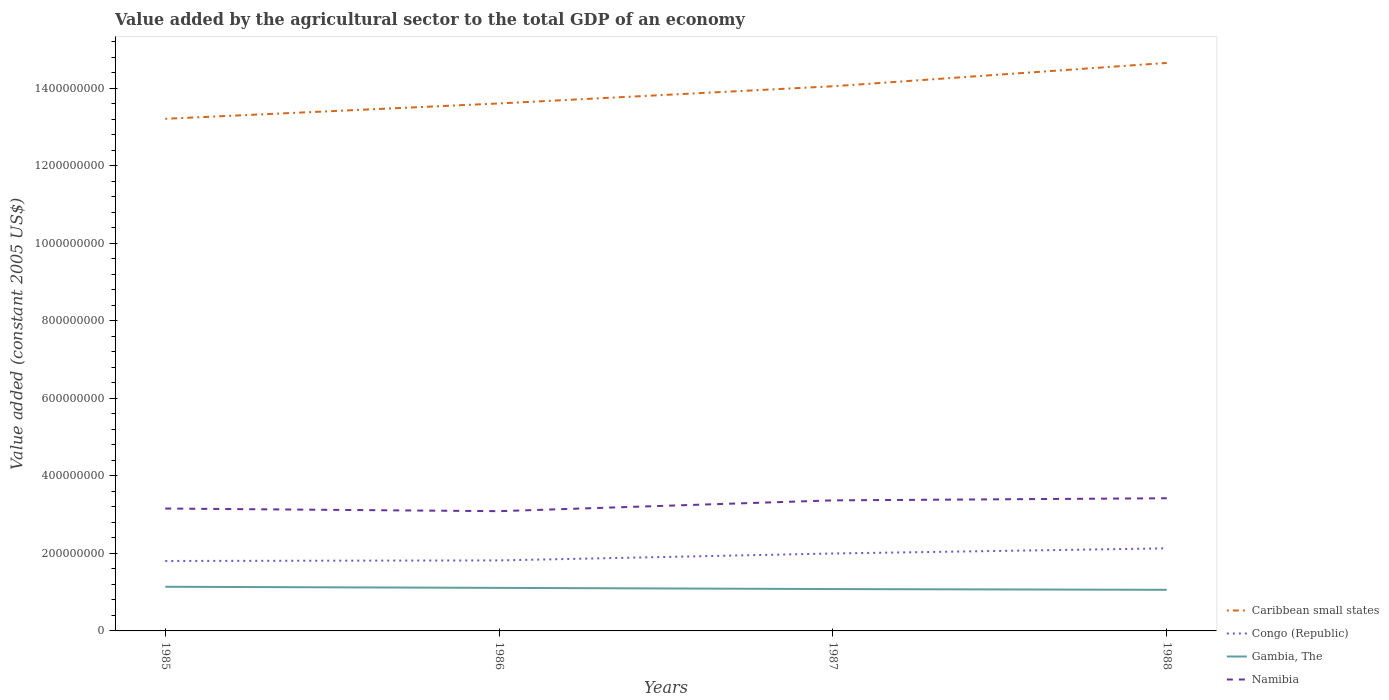How many different coloured lines are there?
Make the answer very short. 4. Does the line corresponding to Gambia, The intersect with the line corresponding to Namibia?
Keep it short and to the point. No. Across all years, what is the maximum value added by the agricultural sector in Congo (Republic)?
Offer a terse response. 1.80e+08. In which year was the value added by the agricultural sector in Caribbean small states maximum?
Your answer should be very brief. 1985. What is the total value added by the agricultural sector in Caribbean small states in the graph?
Keep it short and to the point. -6.02e+07. What is the difference between the highest and the second highest value added by the agricultural sector in Congo (Republic)?
Make the answer very short. 3.26e+07. What is the difference between the highest and the lowest value added by the agricultural sector in Namibia?
Offer a very short reply. 2. Is the value added by the agricultural sector in Namibia strictly greater than the value added by the agricultural sector in Gambia, The over the years?
Provide a succinct answer. No. What is the difference between two consecutive major ticks on the Y-axis?
Ensure brevity in your answer.  2.00e+08. Does the graph contain grids?
Ensure brevity in your answer.  No. How many legend labels are there?
Offer a terse response. 4. What is the title of the graph?
Provide a short and direct response. Value added by the agricultural sector to the total GDP of an economy. What is the label or title of the X-axis?
Make the answer very short. Years. What is the label or title of the Y-axis?
Offer a very short reply. Value added (constant 2005 US$). What is the Value added (constant 2005 US$) in Caribbean small states in 1985?
Provide a short and direct response. 1.32e+09. What is the Value added (constant 2005 US$) of Congo (Republic) in 1985?
Make the answer very short. 1.80e+08. What is the Value added (constant 2005 US$) of Gambia, The in 1985?
Make the answer very short. 1.14e+08. What is the Value added (constant 2005 US$) in Namibia in 1985?
Offer a terse response. 3.16e+08. What is the Value added (constant 2005 US$) of Caribbean small states in 1986?
Give a very brief answer. 1.36e+09. What is the Value added (constant 2005 US$) of Congo (Republic) in 1986?
Give a very brief answer. 1.82e+08. What is the Value added (constant 2005 US$) in Gambia, The in 1986?
Provide a short and direct response. 1.11e+08. What is the Value added (constant 2005 US$) in Namibia in 1986?
Ensure brevity in your answer.  3.09e+08. What is the Value added (constant 2005 US$) of Caribbean small states in 1987?
Your answer should be very brief. 1.41e+09. What is the Value added (constant 2005 US$) in Congo (Republic) in 1987?
Keep it short and to the point. 2.00e+08. What is the Value added (constant 2005 US$) of Gambia, The in 1987?
Your response must be concise. 1.08e+08. What is the Value added (constant 2005 US$) of Namibia in 1987?
Make the answer very short. 3.37e+08. What is the Value added (constant 2005 US$) in Caribbean small states in 1988?
Your answer should be very brief. 1.47e+09. What is the Value added (constant 2005 US$) in Congo (Republic) in 1988?
Your answer should be compact. 2.13e+08. What is the Value added (constant 2005 US$) in Gambia, The in 1988?
Your answer should be compact. 1.06e+08. What is the Value added (constant 2005 US$) in Namibia in 1988?
Your response must be concise. 3.42e+08. Across all years, what is the maximum Value added (constant 2005 US$) in Caribbean small states?
Make the answer very short. 1.47e+09. Across all years, what is the maximum Value added (constant 2005 US$) in Congo (Republic)?
Provide a short and direct response. 2.13e+08. Across all years, what is the maximum Value added (constant 2005 US$) of Gambia, The?
Your response must be concise. 1.14e+08. Across all years, what is the maximum Value added (constant 2005 US$) in Namibia?
Your answer should be compact. 3.42e+08. Across all years, what is the minimum Value added (constant 2005 US$) of Caribbean small states?
Make the answer very short. 1.32e+09. Across all years, what is the minimum Value added (constant 2005 US$) in Congo (Republic)?
Offer a very short reply. 1.80e+08. Across all years, what is the minimum Value added (constant 2005 US$) of Gambia, The?
Provide a succinct answer. 1.06e+08. Across all years, what is the minimum Value added (constant 2005 US$) of Namibia?
Provide a short and direct response. 3.09e+08. What is the total Value added (constant 2005 US$) in Caribbean small states in the graph?
Give a very brief answer. 5.55e+09. What is the total Value added (constant 2005 US$) of Congo (Republic) in the graph?
Provide a short and direct response. 7.75e+08. What is the total Value added (constant 2005 US$) in Gambia, The in the graph?
Make the answer very short. 4.39e+08. What is the total Value added (constant 2005 US$) in Namibia in the graph?
Give a very brief answer. 1.30e+09. What is the difference between the Value added (constant 2005 US$) of Caribbean small states in 1985 and that in 1986?
Your answer should be very brief. -3.96e+07. What is the difference between the Value added (constant 2005 US$) of Congo (Republic) in 1985 and that in 1986?
Give a very brief answer. -1.46e+06. What is the difference between the Value added (constant 2005 US$) in Gambia, The in 1985 and that in 1986?
Your answer should be very brief. 2.87e+06. What is the difference between the Value added (constant 2005 US$) in Namibia in 1985 and that in 1986?
Your answer should be very brief. 6.80e+06. What is the difference between the Value added (constant 2005 US$) in Caribbean small states in 1985 and that in 1987?
Give a very brief answer. -8.39e+07. What is the difference between the Value added (constant 2005 US$) of Congo (Republic) in 1985 and that in 1987?
Provide a short and direct response. -1.93e+07. What is the difference between the Value added (constant 2005 US$) in Gambia, The in 1985 and that in 1987?
Your answer should be very brief. 5.93e+06. What is the difference between the Value added (constant 2005 US$) of Namibia in 1985 and that in 1987?
Ensure brevity in your answer.  -2.11e+07. What is the difference between the Value added (constant 2005 US$) in Caribbean small states in 1985 and that in 1988?
Your response must be concise. -1.44e+08. What is the difference between the Value added (constant 2005 US$) in Congo (Republic) in 1985 and that in 1988?
Offer a terse response. -3.26e+07. What is the difference between the Value added (constant 2005 US$) of Gambia, The in 1985 and that in 1988?
Provide a succinct answer. 7.88e+06. What is the difference between the Value added (constant 2005 US$) in Namibia in 1985 and that in 1988?
Your answer should be very brief. -2.65e+07. What is the difference between the Value added (constant 2005 US$) of Caribbean small states in 1986 and that in 1987?
Make the answer very short. -4.43e+07. What is the difference between the Value added (constant 2005 US$) of Congo (Republic) in 1986 and that in 1987?
Offer a terse response. -1.79e+07. What is the difference between the Value added (constant 2005 US$) in Gambia, The in 1986 and that in 1987?
Give a very brief answer. 3.06e+06. What is the difference between the Value added (constant 2005 US$) of Namibia in 1986 and that in 1987?
Offer a very short reply. -2.79e+07. What is the difference between the Value added (constant 2005 US$) in Caribbean small states in 1986 and that in 1988?
Offer a terse response. -1.05e+08. What is the difference between the Value added (constant 2005 US$) of Congo (Republic) in 1986 and that in 1988?
Your answer should be compact. -3.11e+07. What is the difference between the Value added (constant 2005 US$) of Gambia, The in 1986 and that in 1988?
Your answer should be very brief. 5.01e+06. What is the difference between the Value added (constant 2005 US$) of Namibia in 1986 and that in 1988?
Your response must be concise. -3.34e+07. What is the difference between the Value added (constant 2005 US$) in Caribbean small states in 1987 and that in 1988?
Ensure brevity in your answer.  -6.02e+07. What is the difference between the Value added (constant 2005 US$) in Congo (Republic) in 1987 and that in 1988?
Offer a terse response. -1.33e+07. What is the difference between the Value added (constant 2005 US$) in Gambia, The in 1987 and that in 1988?
Offer a terse response. 1.94e+06. What is the difference between the Value added (constant 2005 US$) of Namibia in 1987 and that in 1988?
Provide a succinct answer. -5.46e+06. What is the difference between the Value added (constant 2005 US$) in Caribbean small states in 1985 and the Value added (constant 2005 US$) in Congo (Republic) in 1986?
Your answer should be compact. 1.14e+09. What is the difference between the Value added (constant 2005 US$) in Caribbean small states in 1985 and the Value added (constant 2005 US$) in Gambia, The in 1986?
Offer a terse response. 1.21e+09. What is the difference between the Value added (constant 2005 US$) of Caribbean small states in 1985 and the Value added (constant 2005 US$) of Namibia in 1986?
Your response must be concise. 1.01e+09. What is the difference between the Value added (constant 2005 US$) of Congo (Republic) in 1985 and the Value added (constant 2005 US$) of Gambia, The in 1986?
Keep it short and to the point. 6.94e+07. What is the difference between the Value added (constant 2005 US$) of Congo (Republic) in 1985 and the Value added (constant 2005 US$) of Namibia in 1986?
Offer a very short reply. -1.28e+08. What is the difference between the Value added (constant 2005 US$) in Gambia, The in 1985 and the Value added (constant 2005 US$) in Namibia in 1986?
Provide a short and direct response. -1.95e+08. What is the difference between the Value added (constant 2005 US$) in Caribbean small states in 1985 and the Value added (constant 2005 US$) in Congo (Republic) in 1987?
Offer a terse response. 1.12e+09. What is the difference between the Value added (constant 2005 US$) of Caribbean small states in 1985 and the Value added (constant 2005 US$) of Gambia, The in 1987?
Make the answer very short. 1.21e+09. What is the difference between the Value added (constant 2005 US$) of Caribbean small states in 1985 and the Value added (constant 2005 US$) of Namibia in 1987?
Provide a succinct answer. 9.84e+08. What is the difference between the Value added (constant 2005 US$) in Congo (Republic) in 1985 and the Value added (constant 2005 US$) in Gambia, The in 1987?
Your answer should be very brief. 7.25e+07. What is the difference between the Value added (constant 2005 US$) of Congo (Republic) in 1985 and the Value added (constant 2005 US$) of Namibia in 1987?
Your answer should be compact. -1.56e+08. What is the difference between the Value added (constant 2005 US$) in Gambia, The in 1985 and the Value added (constant 2005 US$) in Namibia in 1987?
Make the answer very short. -2.23e+08. What is the difference between the Value added (constant 2005 US$) of Caribbean small states in 1985 and the Value added (constant 2005 US$) of Congo (Republic) in 1988?
Provide a short and direct response. 1.11e+09. What is the difference between the Value added (constant 2005 US$) in Caribbean small states in 1985 and the Value added (constant 2005 US$) in Gambia, The in 1988?
Offer a very short reply. 1.22e+09. What is the difference between the Value added (constant 2005 US$) of Caribbean small states in 1985 and the Value added (constant 2005 US$) of Namibia in 1988?
Keep it short and to the point. 9.79e+08. What is the difference between the Value added (constant 2005 US$) of Congo (Republic) in 1985 and the Value added (constant 2005 US$) of Gambia, The in 1988?
Your response must be concise. 7.44e+07. What is the difference between the Value added (constant 2005 US$) in Congo (Republic) in 1985 and the Value added (constant 2005 US$) in Namibia in 1988?
Your answer should be very brief. -1.62e+08. What is the difference between the Value added (constant 2005 US$) of Gambia, The in 1985 and the Value added (constant 2005 US$) of Namibia in 1988?
Offer a terse response. -2.28e+08. What is the difference between the Value added (constant 2005 US$) in Caribbean small states in 1986 and the Value added (constant 2005 US$) in Congo (Republic) in 1987?
Your answer should be very brief. 1.16e+09. What is the difference between the Value added (constant 2005 US$) in Caribbean small states in 1986 and the Value added (constant 2005 US$) in Gambia, The in 1987?
Ensure brevity in your answer.  1.25e+09. What is the difference between the Value added (constant 2005 US$) in Caribbean small states in 1986 and the Value added (constant 2005 US$) in Namibia in 1987?
Provide a short and direct response. 1.02e+09. What is the difference between the Value added (constant 2005 US$) of Congo (Republic) in 1986 and the Value added (constant 2005 US$) of Gambia, The in 1987?
Your answer should be compact. 7.39e+07. What is the difference between the Value added (constant 2005 US$) in Congo (Republic) in 1986 and the Value added (constant 2005 US$) in Namibia in 1987?
Your response must be concise. -1.55e+08. What is the difference between the Value added (constant 2005 US$) of Gambia, The in 1986 and the Value added (constant 2005 US$) of Namibia in 1987?
Keep it short and to the point. -2.26e+08. What is the difference between the Value added (constant 2005 US$) in Caribbean small states in 1986 and the Value added (constant 2005 US$) in Congo (Republic) in 1988?
Provide a short and direct response. 1.15e+09. What is the difference between the Value added (constant 2005 US$) in Caribbean small states in 1986 and the Value added (constant 2005 US$) in Gambia, The in 1988?
Ensure brevity in your answer.  1.25e+09. What is the difference between the Value added (constant 2005 US$) in Caribbean small states in 1986 and the Value added (constant 2005 US$) in Namibia in 1988?
Keep it short and to the point. 1.02e+09. What is the difference between the Value added (constant 2005 US$) of Congo (Republic) in 1986 and the Value added (constant 2005 US$) of Gambia, The in 1988?
Provide a succinct answer. 7.59e+07. What is the difference between the Value added (constant 2005 US$) in Congo (Republic) in 1986 and the Value added (constant 2005 US$) in Namibia in 1988?
Your answer should be very brief. -1.60e+08. What is the difference between the Value added (constant 2005 US$) of Gambia, The in 1986 and the Value added (constant 2005 US$) of Namibia in 1988?
Provide a short and direct response. -2.31e+08. What is the difference between the Value added (constant 2005 US$) in Caribbean small states in 1987 and the Value added (constant 2005 US$) in Congo (Republic) in 1988?
Give a very brief answer. 1.19e+09. What is the difference between the Value added (constant 2005 US$) in Caribbean small states in 1987 and the Value added (constant 2005 US$) in Gambia, The in 1988?
Your answer should be very brief. 1.30e+09. What is the difference between the Value added (constant 2005 US$) of Caribbean small states in 1987 and the Value added (constant 2005 US$) of Namibia in 1988?
Provide a succinct answer. 1.06e+09. What is the difference between the Value added (constant 2005 US$) of Congo (Republic) in 1987 and the Value added (constant 2005 US$) of Gambia, The in 1988?
Give a very brief answer. 9.37e+07. What is the difference between the Value added (constant 2005 US$) in Congo (Republic) in 1987 and the Value added (constant 2005 US$) in Namibia in 1988?
Your response must be concise. -1.43e+08. What is the difference between the Value added (constant 2005 US$) in Gambia, The in 1987 and the Value added (constant 2005 US$) in Namibia in 1988?
Offer a very short reply. -2.34e+08. What is the average Value added (constant 2005 US$) in Caribbean small states per year?
Your answer should be very brief. 1.39e+09. What is the average Value added (constant 2005 US$) of Congo (Republic) per year?
Provide a short and direct response. 1.94e+08. What is the average Value added (constant 2005 US$) of Gambia, The per year?
Ensure brevity in your answer.  1.10e+08. What is the average Value added (constant 2005 US$) in Namibia per year?
Your response must be concise. 3.26e+08. In the year 1985, what is the difference between the Value added (constant 2005 US$) in Caribbean small states and Value added (constant 2005 US$) in Congo (Republic)?
Your answer should be very brief. 1.14e+09. In the year 1985, what is the difference between the Value added (constant 2005 US$) in Caribbean small states and Value added (constant 2005 US$) in Gambia, The?
Give a very brief answer. 1.21e+09. In the year 1985, what is the difference between the Value added (constant 2005 US$) of Caribbean small states and Value added (constant 2005 US$) of Namibia?
Provide a succinct answer. 1.01e+09. In the year 1985, what is the difference between the Value added (constant 2005 US$) of Congo (Republic) and Value added (constant 2005 US$) of Gambia, The?
Provide a succinct answer. 6.65e+07. In the year 1985, what is the difference between the Value added (constant 2005 US$) of Congo (Republic) and Value added (constant 2005 US$) of Namibia?
Offer a very short reply. -1.35e+08. In the year 1985, what is the difference between the Value added (constant 2005 US$) in Gambia, The and Value added (constant 2005 US$) in Namibia?
Provide a succinct answer. -2.02e+08. In the year 1986, what is the difference between the Value added (constant 2005 US$) of Caribbean small states and Value added (constant 2005 US$) of Congo (Republic)?
Keep it short and to the point. 1.18e+09. In the year 1986, what is the difference between the Value added (constant 2005 US$) in Caribbean small states and Value added (constant 2005 US$) in Gambia, The?
Ensure brevity in your answer.  1.25e+09. In the year 1986, what is the difference between the Value added (constant 2005 US$) of Caribbean small states and Value added (constant 2005 US$) of Namibia?
Your answer should be compact. 1.05e+09. In the year 1986, what is the difference between the Value added (constant 2005 US$) of Congo (Republic) and Value added (constant 2005 US$) of Gambia, The?
Your answer should be very brief. 7.09e+07. In the year 1986, what is the difference between the Value added (constant 2005 US$) of Congo (Republic) and Value added (constant 2005 US$) of Namibia?
Keep it short and to the point. -1.27e+08. In the year 1986, what is the difference between the Value added (constant 2005 US$) of Gambia, The and Value added (constant 2005 US$) of Namibia?
Your answer should be compact. -1.98e+08. In the year 1987, what is the difference between the Value added (constant 2005 US$) in Caribbean small states and Value added (constant 2005 US$) in Congo (Republic)?
Offer a terse response. 1.21e+09. In the year 1987, what is the difference between the Value added (constant 2005 US$) of Caribbean small states and Value added (constant 2005 US$) of Gambia, The?
Give a very brief answer. 1.30e+09. In the year 1987, what is the difference between the Value added (constant 2005 US$) in Caribbean small states and Value added (constant 2005 US$) in Namibia?
Give a very brief answer. 1.07e+09. In the year 1987, what is the difference between the Value added (constant 2005 US$) of Congo (Republic) and Value added (constant 2005 US$) of Gambia, The?
Your answer should be very brief. 9.18e+07. In the year 1987, what is the difference between the Value added (constant 2005 US$) in Congo (Republic) and Value added (constant 2005 US$) in Namibia?
Provide a short and direct response. -1.37e+08. In the year 1987, what is the difference between the Value added (constant 2005 US$) in Gambia, The and Value added (constant 2005 US$) in Namibia?
Give a very brief answer. -2.29e+08. In the year 1988, what is the difference between the Value added (constant 2005 US$) in Caribbean small states and Value added (constant 2005 US$) in Congo (Republic)?
Your answer should be very brief. 1.25e+09. In the year 1988, what is the difference between the Value added (constant 2005 US$) of Caribbean small states and Value added (constant 2005 US$) of Gambia, The?
Ensure brevity in your answer.  1.36e+09. In the year 1988, what is the difference between the Value added (constant 2005 US$) of Caribbean small states and Value added (constant 2005 US$) of Namibia?
Your answer should be very brief. 1.12e+09. In the year 1988, what is the difference between the Value added (constant 2005 US$) in Congo (Republic) and Value added (constant 2005 US$) in Gambia, The?
Offer a very short reply. 1.07e+08. In the year 1988, what is the difference between the Value added (constant 2005 US$) in Congo (Republic) and Value added (constant 2005 US$) in Namibia?
Your answer should be compact. -1.29e+08. In the year 1988, what is the difference between the Value added (constant 2005 US$) in Gambia, The and Value added (constant 2005 US$) in Namibia?
Give a very brief answer. -2.36e+08. What is the ratio of the Value added (constant 2005 US$) in Caribbean small states in 1985 to that in 1986?
Provide a short and direct response. 0.97. What is the ratio of the Value added (constant 2005 US$) of Congo (Republic) in 1985 to that in 1986?
Provide a short and direct response. 0.99. What is the ratio of the Value added (constant 2005 US$) in Gambia, The in 1985 to that in 1986?
Keep it short and to the point. 1.03. What is the ratio of the Value added (constant 2005 US$) in Namibia in 1985 to that in 1986?
Provide a succinct answer. 1.02. What is the ratio of the Value added (constant 2005 US$) of Caribbean small states in 1985 to that in 1987?
Your answer should be compact. 0.94. What is the ratio of the Value added (constant 2005 US$) in Congo (Republic) in 1985 to that in 1987?
Make the answer very short. 0.9. What is the ratio of the Value added (constant 2005 US$) in Gambia, The in 1985 to that in 1987?
Your answer should be very brief. 1.05. What is the ratio of the Value added (constant 2005 US$) in Namibia in 1985 to that in 1987?
Keep it short and to the point. 0.94. What is the ratio of the Value added (constant 2005 US$) of Caribbean small states in 1985 to that in 1988?
Keep it short and to the point. 0.9. What is the ratio of the Value added (constant 2005 US$) of Congo (Republic) in 1985 to that in 1988?
Offer a very short reply. 0.85. What is the ratio of the Value added (constant 2005 US$) in Gambia, The in 1985 to that in 1988?
Give a very brief answer. 1.07. What is the ratio of the Value added (constant 2005 US$) in Namibia in 1985 to that in 1988?
Your answer should be very brief. 0.92. What is the ratio of the Value added (constant 2005 US$) in Caribbean small states in 1986 to that in 1987?
Ensure brevity in your answer.  0.97. What is the ratio of the Value added (constant 2005 US$) in Congo (Republic) in 1986 to that in 1987?
Your response must be concise. 0.91. What is the ratio of the Value added (constant 2005 US$) in Gambia, The in 1986 to that in 1987?
Give a very brief answer. 1.03. What is the ratio of the Value added (constant 2005 US$) in Namibia in 1986 to that in 1987?
Offer a very short reply. 0.92. What is the ratio of the Value added (constant 2005 US$) in Caribbean small states in 1986 to that in 1988?
Give a very brief answer. 0.93. What is the ratio of the Value added (constant 2005 US$) of Congo (Republic) in 1986 to that in 1988?
Provide a short and direct response. 0.85. What is the ratio of the Value added (constant 2005 US$) in Gambia, The in 1986 to that in 1988?
Your response must be concise. 1.05. What is the ratio of the Value added (constant 2005 US$) in Namibia in 1986 to that in 1988?
Your response must be concise. 0.9. What is the ratio of the Value added (constant 2005 US$) of Caribbean small states in 1987 to that in 1988?
Your answer should be very brief. 0.96. What is the ratio of the Value added (constant 2005 US$) of Congo (Republic) in 1987 to that in 1988?
Keep it short and to the point. 0.94. What is the ratio of the Value added (constant 2005 US$) in Gambia, The in 1987 to that in 1988?
Give a very brief answer. 1.02. What is the ratio of the Value added (constant 2005 US$) in Namibia in 1987 to that in 1988?
Provide a succinct answer. 0.98. What is the difference between the highest and the second highest Value added (constant 2005 US$) in Caribbean small states?
Your response must be concise. 6.02e+07. What is the difference between the highest and the second highest Value added (constant 2005 US$) of Congo (Republic)?
Provide a succinct answer. 1.33e+07. What is the difference between the highest and the second highest Value added (constant 2005 US$) of Gambia, The?
Make the answer very short. 2.87e+06. What is the difference between the highest and the second highest Value added (constant 2005 US$) of Namibia?
Provide a succinct answer. 5.46e+06. What is the difference between the highest and the lowest Value added (constant 2005 US$) of Caribbean small states?
Your answer should be compact. 1.44e+08. What is the difference between the highest and the lowest Value added (constant 2005 US$) in Congo (Republic)?
Provide a short and direct response. 3.26e+07. What is the difference between the highest and the lowest Value added (constant 2005 US$) of Gambia, The?
Your answer should be very brief. 7.88e+06. What is the difference between the highest and the lowest Value added (constant 2005 US$) in Namibia?
Provide a succinct answer. 3.34e+07. 